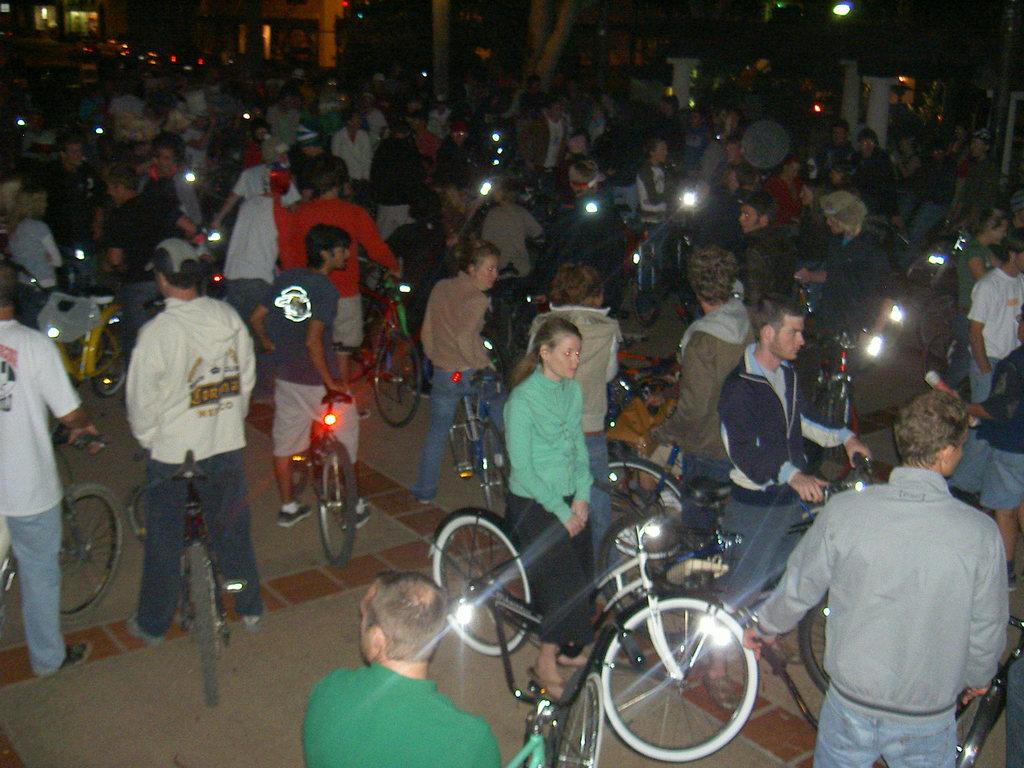How many people are in the image? There is a group of people in the image, but the exact number is not specified. What are some people doing in the image? Some people are holding bicycles in the image. What additional objects can be seen in the image? There are torch lights in the image. What type of crack is being served in the image? There is no crack present in the image; it features a group of people holding bicycles and torch lights. How much money is visible in the image? There is no mention of money in the image; it focuses on people holding bicycles and the presence of torch lights. 